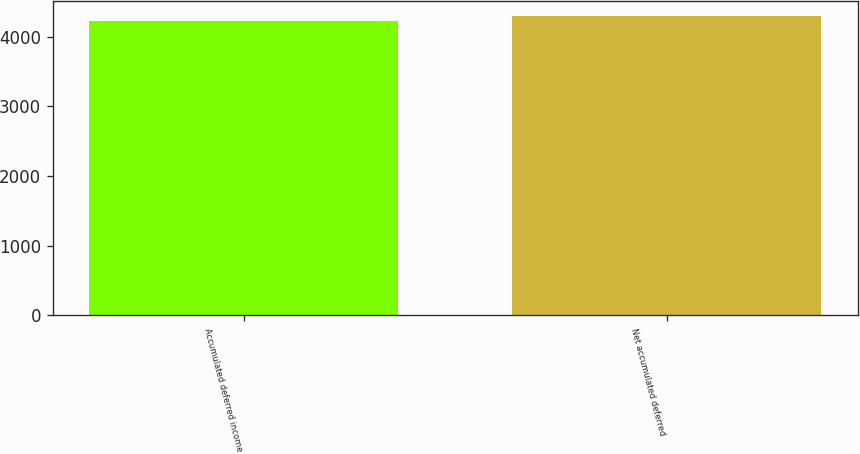Convert chart. <chart><loc_0><loc_0><loc_500><loc_500><bar_chart><fcel>Accumulated deferred income<fcel>Net accumulated deferred<nl><fcel>4231<fcel>4299<nl></chart> 